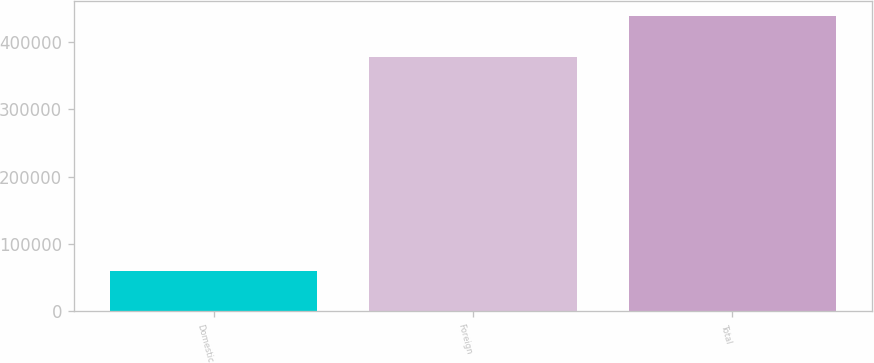<chart> <loc_0><loc_0><loc_500><loc_500><bar_chart><fcel>Domestic<fcel>Foreign<fcel>Total<nl><fcel>60470<fcel>377393<fcel>437863<nl></chart> 